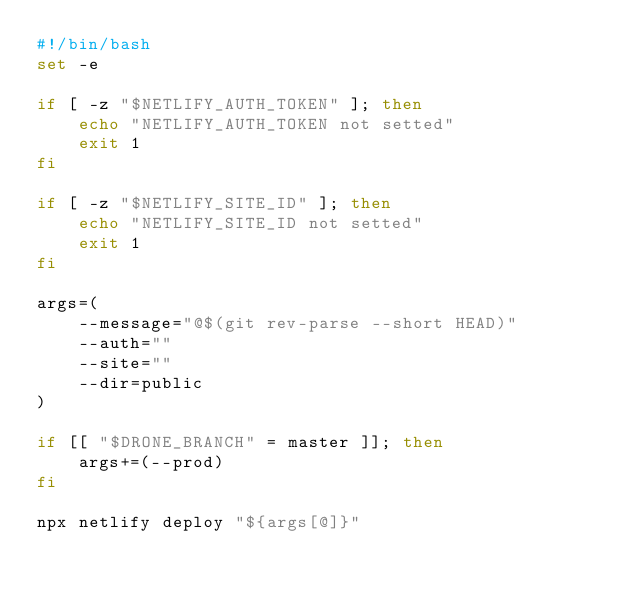<code> <loc_0><loc_0><loc_500><loc_500><_Bash_>#!/bin/bash
set -e

if [ -z "$NETLIFY_AUTH_TOKEN" ]; then
    echo "NETLIFY_AUTH_TOKEN not setted"
    exit 1
fi

if [ -z "$NETLIFY_SITE_ID" ]; then
    echo "NETLIFY_SITE_ID not setted"
    exit 1
fi

args=(
    --message="@$(git rev-parse --short HEAD)"
    --auth=""
    --site=""
    --dir=public
)

if [[ "$DRONE_BRANCH" = master ]]; then
    args+=(--prod)
fi
  
npx netlify deploy "${args[@]}"</code> 